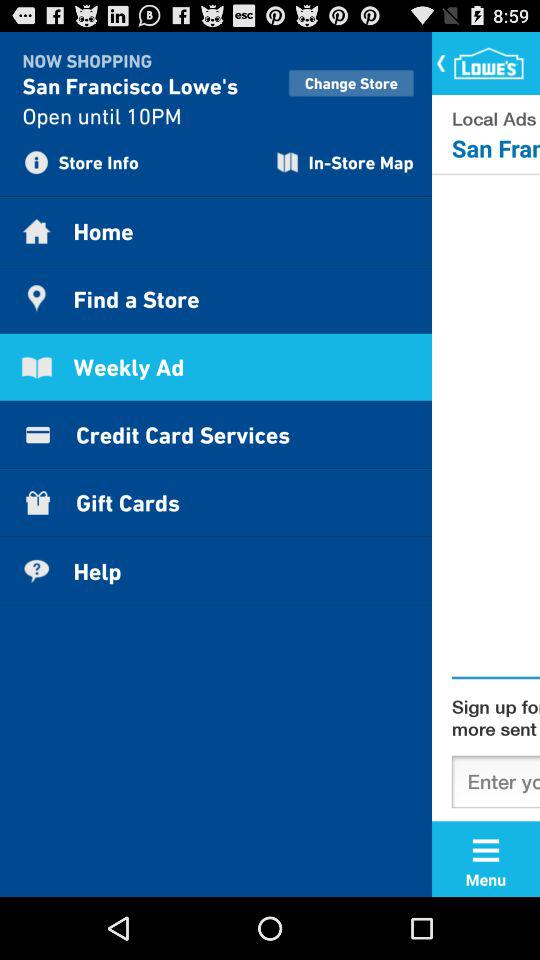Until what time is "San Francisco Lowe's" open? The San Francisco Lowe's is open until 10 PM. 